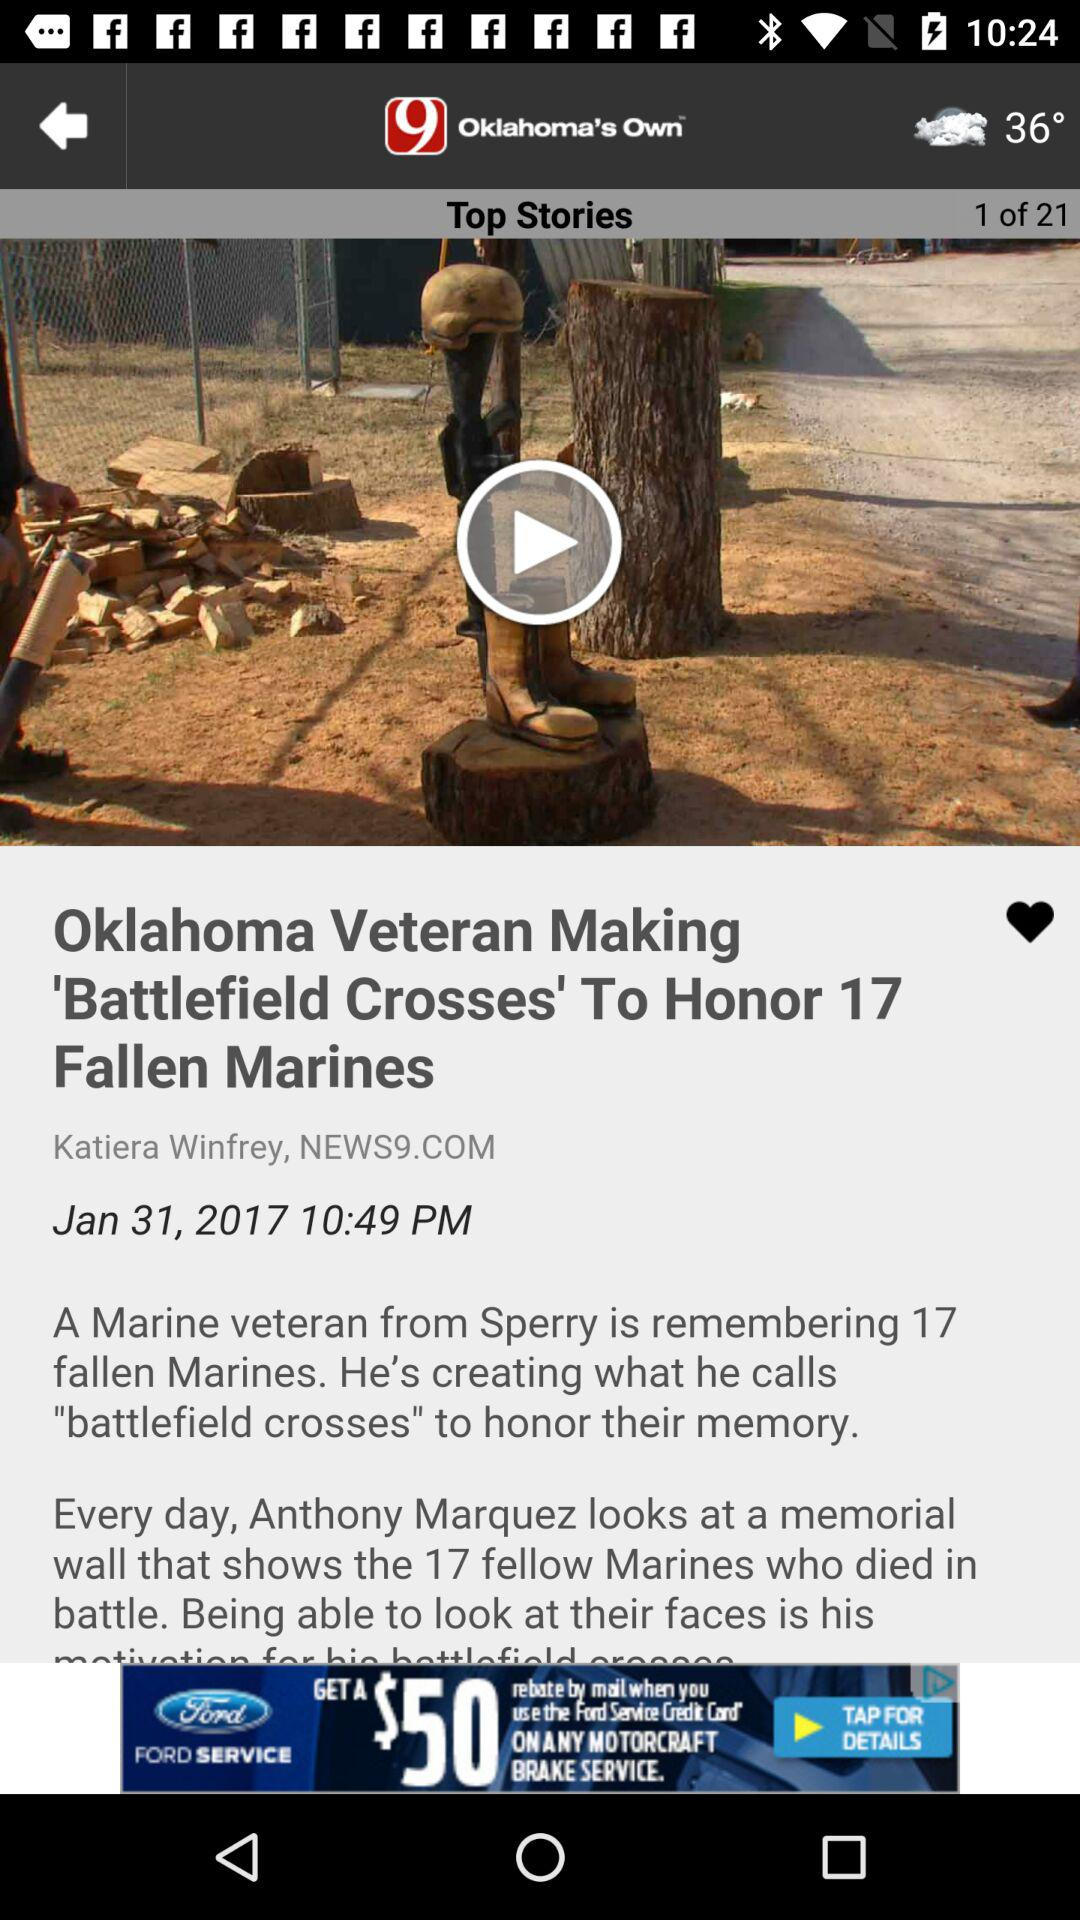What is the time? The time is 10:49 PM. 